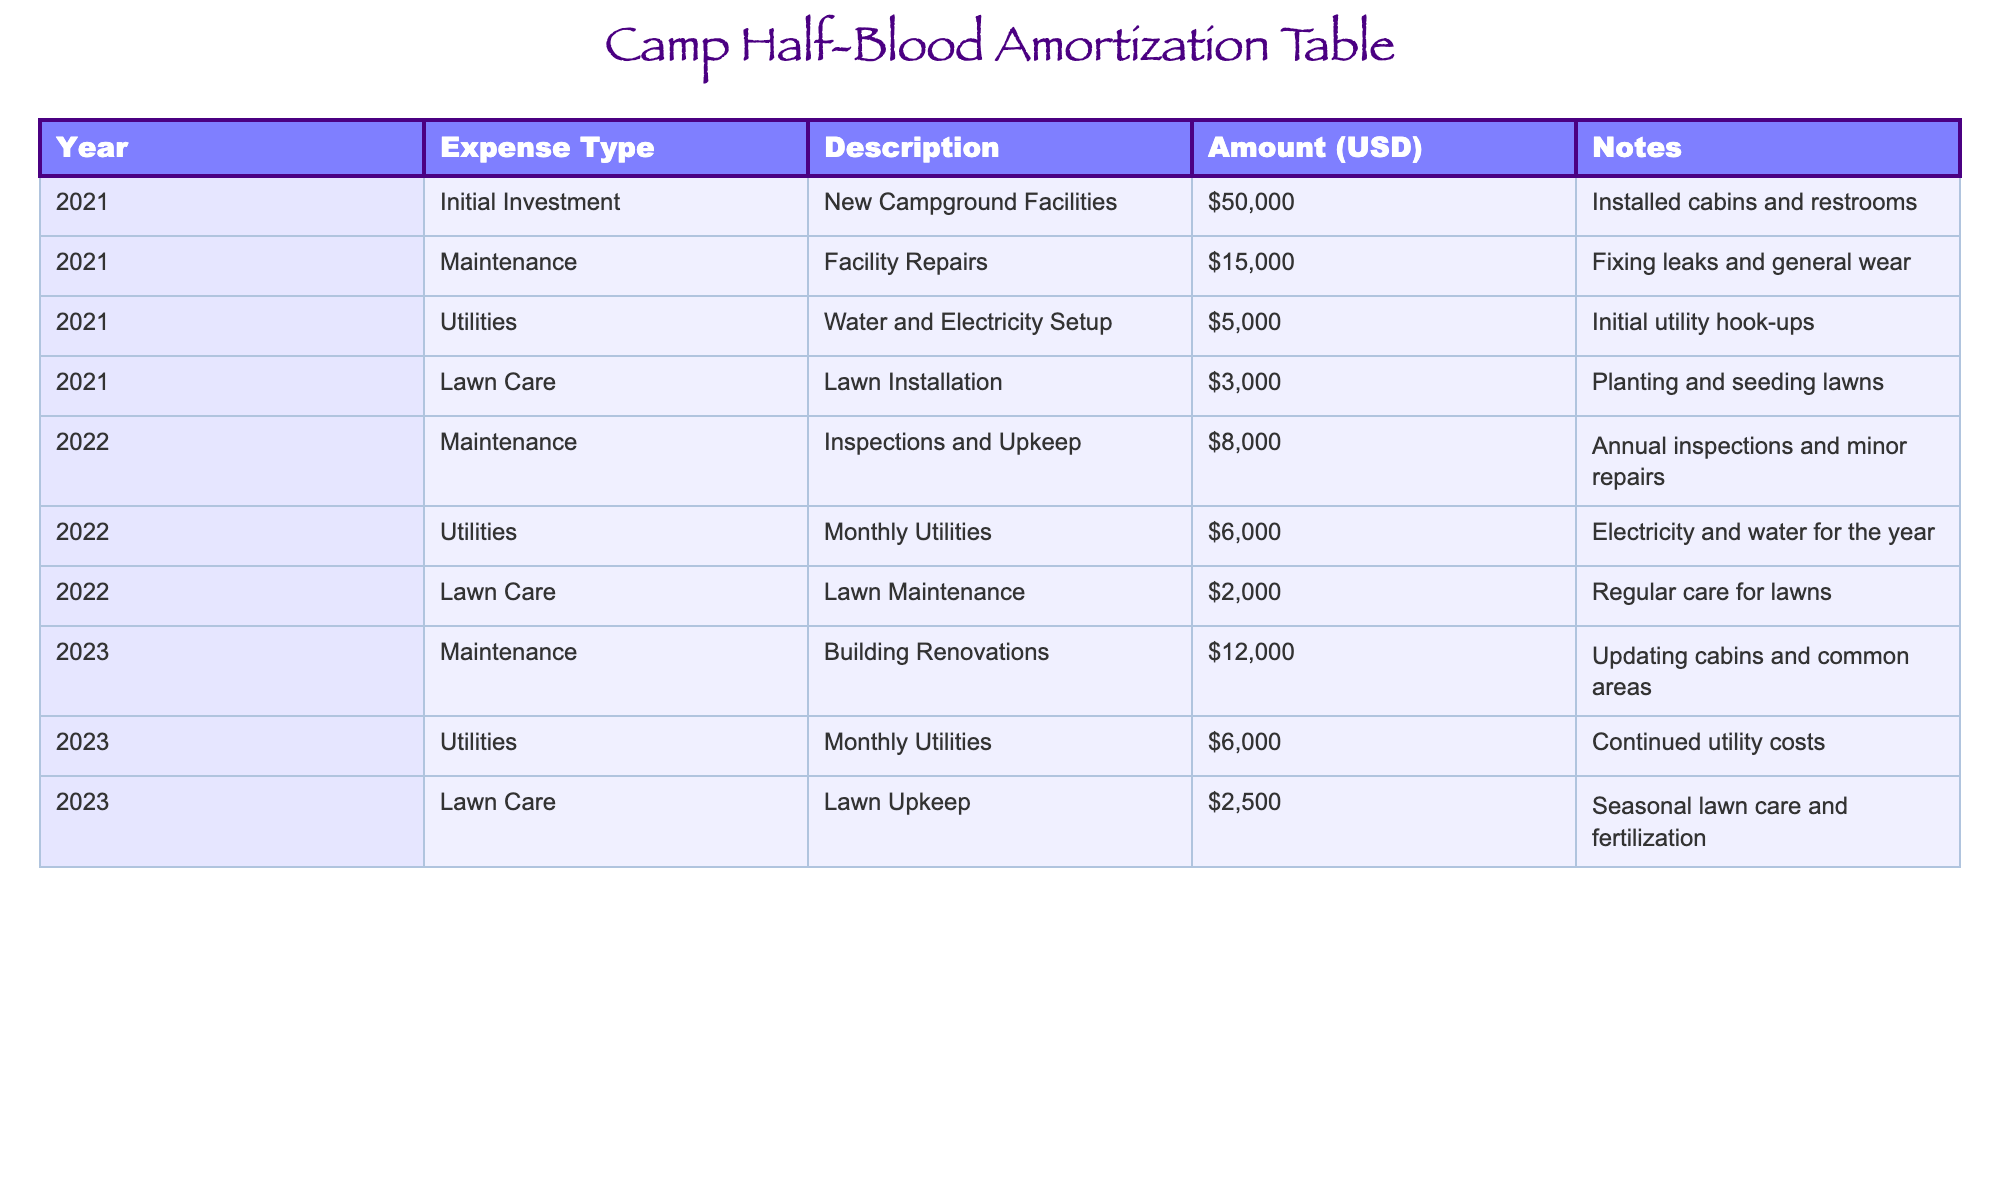What is the total amount spent on lawn care over three years? By summing the amounts listed under lawn care for each year, we find 3000 (2021) + 2000 (2022) + 2500 (2023) = 7500.
Answer: 7500 What was the expense for utilities in 2021? The table indicates that the expense for utilities in 2021 was 5000.
Answer: 5000 Which year had the highest maintenance expense? Examining the maintenance expenses: 15000 (2021) + 8000 (2022) + 12000 (2023) shows 15000 is the highest value in 2021.
Answer: 2021 Did the expenses for lawn maintenance increase from 2022 to 2023? The expenses for lawn maintenance were 2000 in 2022 and 2500 in 2023, indicating an increase.
Answer: Yes What are the total expenses across all categories for the year 2022? For 2022, the expenses are 8000 (maintenance) + 6000 (utilities) + 2000 (lawn care), totaling 16000.
Answer: 16000 Is the total of initial investments higher than the total maintenance expenses over three years? The initial investment is 50000, while maintenance expenses total 15000 (2021) + 8000 (2022) + 12000 (2023) = 35000, thus yes, the initial investment is higher.
Answer: Yes What was the average monthly utility cost for 2022 and 2023 combined? The total utility amount for 2022 is 6000 and for 2023 is also 6000, totalling 12000. Considering 24 months, the average is 12000/24 = 500.
Answer: 500 What is the total amount spent on maintenance in 2023 compared to 2021? The amount spent on maintenance in 2023 was 12000 and in 2021 was 15000. Comparing these shows 15000 is higher than 12000.
Answer: 15000 in 2021 Which expense type had the least amount over the three years? Lawn care had 3000 (2021) + 2000 (2022) + 2500 (2023) = 7500, which is less than the total of other expense types.
Answer: Lawn care 